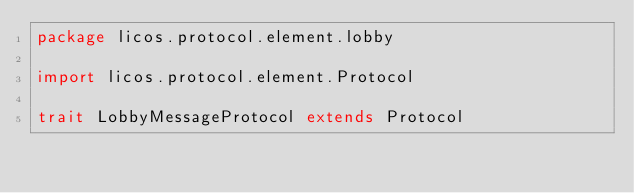<code> <loc_0><loc_0><loc_500><loc_500><_Scala_>package licos.protocol.element.lobby

import licos.protocol.element.Protocol

trait LobbyMessageProtocol extends Protocol
</code> 